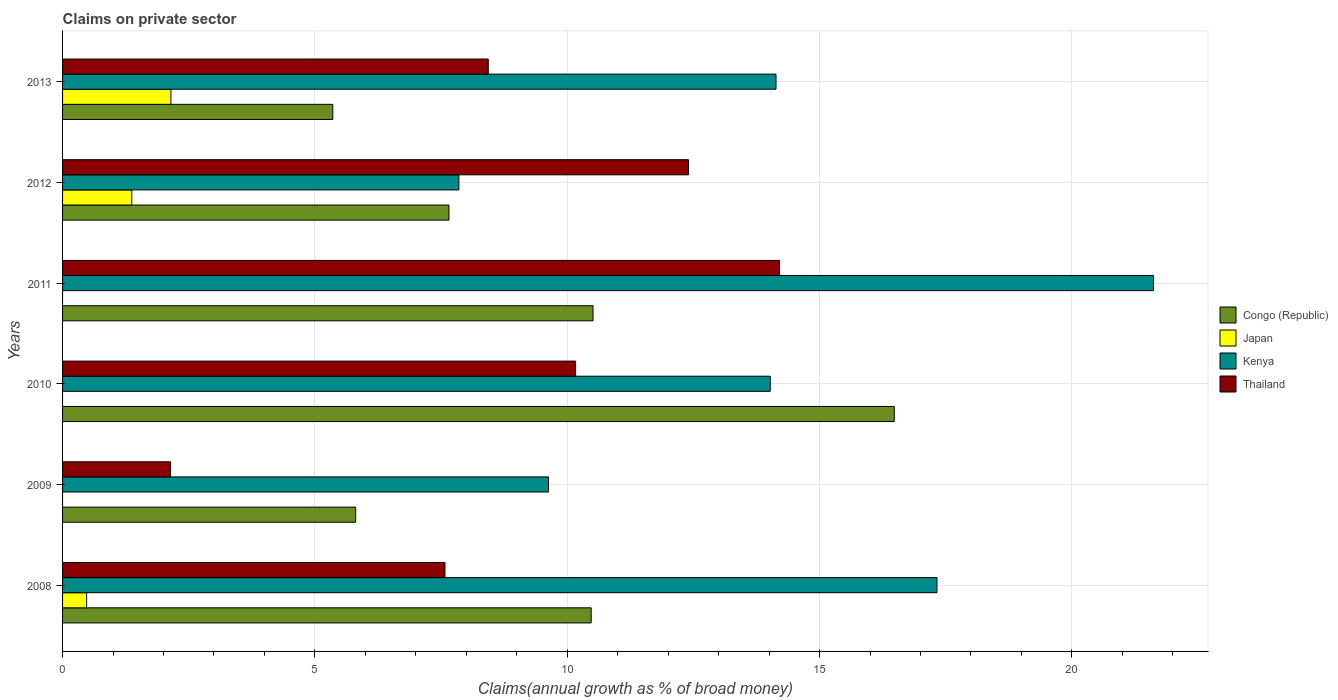How many different coloured bars are there?
Your answer should be compact. 4. How many groups of bars are there?
Provide a short and direct response. 6. How many bars are there on the 4th tick from the bottom?
Give a very brief answer. 3. What is the label of the 3rd group of bars from the top?
Provide a short and direct response. 2011. What is the percentage of broad money claimed on private sector in Congo (Republic) in 2012?
Your answer should be compact. 7.66. Across all years, what is the maximum percentage of broad money claimed on private sector in Congo (Republic)?
Your answer should be very brief. 16.48. Across all years, what is the minimum percentage of broad money claimed on private sector in Kenya?
Give a very brief answer. 7.85. In which year was the percentage of broad money claimed on private sector in Thailand maximum?
Your answer should be compact. 2011. What is the total percentage of broad money claimed on private sector in Thailand in the graph?
Offer a very short reply. 54.93. What is the difference between the percentage of broad money claimed on private sector in Congo (Republic) in 2008 and that in 2012?
Your response must be concise. 2.82. What is the difference between the percentage of broad money claimed on private sector in Congo (Republic) in 2010 and the percentage of broad money claimed on private sector in Kenya in 2011?
Provide a succinct answer. -5.14. What is the average percentage of broad money claimed on private sector in Kenya per year?
Provide a succinct answer. 14.1. In the year 2013, what is the difference between the percentage of broad money claimed on private sector in Congo (Republic) and percentage of broad money claimed on private sector in Thailand?
Keep it short and to the point. -3.08. What is the ratio of the percentage of broad money claimed on private sector in Congo (Republic) in 2009 to that in 2013?
Provide a succinct answer. 1.08. Is the difference between the percentage of broad money claimed on private sector in Congo (Republic) in 2009 and 2012 greater than the difference between the percentage of broad money claimed on private sector in Thailand in 2009 and 2012?
Offer a very short reply. Yes. What is the difference between the highest and the second highest percentage of broad money claimed on private sector in Congo (Republic)?
Your answer should be compact. 5.97. What is the difference between the highest and the lowest percentage of broad money claimed on private sector in Congo (Republic)?
Your answer should be compact. 11.13. Is it the case that in every year, the sum of the percentage of broad money claimed on private sector in Kenya and percentage of broad money claimed on private sector in Thailand is greater than the sum of percentage of broad money claimed on private sector in Japan and percentage of broad money claimed on private sector in Congo (Republic)?
Ensure brevity in your answer.  No. Is it the case that in every year, the sum of the percentage of broad money claimed on private sector in Kenya and percentage of broad money claimed on private sector in Japan is greater than the percentage of broad money claimed on private sector in Thailand?
Your answer should be very brief. No. Are all the bars in the graph horizontal?
Offer a terse response. Yes. What is the difference between two consecutive major ticks on the X-axis?
Make the answer very short. 5. Are the values on the major ticks of X-axis written in scientific E-notation?
Offer a very short reply. No. How many legend labels are there?
Offer a very short reply. 4. What is the title of the graph?
Give a very brief answer. Claims on private sector. Does "North America" appear as one of the legend labels in the graph?
Give a very brief answer. No. What is the label or title of the X-axis?
Offer a terse response. Claims(annual growth as % of broad money). What is the Claims(annual growth as % of broad money) in Congo (Republic) in 2008?
Provide a succinct answer. 10.47. What is the Claims(annual growth as % of broad money) of Japan in 2008?
Offer a terse response. 0.48. What is the Claims(annual growth as % of broad money) of Kenya in 2008?
Provide a short and direct response. 17.33. What is the Claims(annual growth as % of broad money) of Thailand in 2008?
Provide a short and direct response. 7.58. What is the Claims(annual growth as % of broad money) of Congo (Republic) in 2009?
Ensure brevity in your answer.  5.81. What is the Claims(annual growth as % of broad money) in Kenya in 2009?
Give a very brief answer. 9.63. What is the Claims(annual growth as % of broad money) in Thailand in 2009?
Provide a succinct answer. 2.14. What is the Claims(annual growth as % of broad money) in Congo (Republic) in 2010?
Offer a very short reply. 16.48. What is the Claims(annual growth as % of broad money) of Japan in 2010?
Your answer should be compact. 0. What is the Claims(annual growth as % of broad money) of Kenya in 2010?
Your answer should be very brief. 14.02. What is the Claims(annual growth as % of broad money) in Thailand in 2010?
Give a very brief answer. 10.17. What is the Claims(annual growth as % of broad money) in Congo (Republic) in 2011?
Offer a terse response. 10.51. What is the Claims(annual growth as % of broad money) in Japan in 2011?
Your response must be concise. 0. What is the Claims(annual growth as % of broad money) of Kenya in 2011?
Your response must be concise. 21.62. What is the Claims(annual growth as % of broad money) of Thailand in 2011?
Give a very brief answer. 14.21. What is the Claims(annual growth as % of broad money) of Congo (Republic) in 2012?
Keep it short and to the point. 7.66. What is the Claims(annual growth as % of broad money) in Japan in 2012?
Your answer should be very brief. 1.37. What is the Claims(annual growth as % of broad money) in Kenya in 2012?
Offer a very short reply. 7.85. What is the Claims(annual growth as % of broad money) in Thailand in 2012?
Keep it short and to the point. 12.4. What is the Claims(annual growth as % of broad money) of Congo (Republic) in 2013?
Provide a short and direct response. 5.35. What is the Claims(annual growth as % of broad money) of Japan in 2013?
Make the answer very short. 2.15. What is the Claims(annual growth as % of broad money) of Kenya in 2013?
Keep it short and to the point. 14.14. What is the Claims(annual growth as % of broad money) in Thailand in 2013?
Provide a succinct answer. 8.44. Across all years, what is the maximum Claims(annual growth as % of broad money) of Congo (Republic)?
Your answer should be compact. 16.48. Across all years, what is the maximum Claims(annual growth as % of broad money) in Japan?
Keep it short and to the point. 2.15. Across all years, what is the maximum Claims(annual growth as % of broad money) in Kenya?
Make the answer very short. 21.62. Across all years, what is the maximum Claims(annual growth as % of broad money) in Thailand?
Ensure brevity in your answer.  14.21. Across all years, what is the minimum Claims(annual growth as % of broad money) of Congo (Republic)?
Your answer should be compact. 5.35. Across all years, what is the minimum Claims(annual growth as % of broad money) in Kenya?
Your answer should be compact. 7.85. Across all years, what is the minimum Claims(annual growth as % of broad money) of Thailand?
Offer a terse response. 2.14. What is the total Claims(annual growth as % of broad money) of Congo (Republic) in the graph?
Give a very brief answer. 56.29. What is the total Claims(annual growth as % of broad money) in Japan in the graph?
Provide a short and direct response. 3.99. What is the total Claims(annual growth as % of broad money) in Kenya in the graph?
Provide a succinct answer. 84.59. What is the total Claims(annual growth as % of broad money) of Thailand in the graph?
Provide a succinct answer. 54.93. What is the difference between the Claims(annual growth as % of broad money) in Congo (Republic) in 2008 and that in 2009?
Make the answer very short. 4.67. What is the difference between the Claims(annual growth as % of broad money) of Kenya in 2008 and that in 2009?
Ensure brevity in your answer.  7.7. What is the difference between the Claims(annual growth as % of broad money) in Thailand in 2008 and that in 2009?
Offer a very short reply. 5.44. What is the difference between the Claims(annual growth as % of broad money) in Congo (Republic) in 2008 and that in 2010?
Your answer should be compact. -6.01. What is the difference between the Claims(annual growth as % of broad money) of Kenya in 2008 and that in 2010?
Offer a terse response. 3.3. What is the difference between the Claims(annual growth as % of broad money) of Thailand in 2008 and that in 2010?
Keep it short and to the point. -2.59. What is the difference between the Claims(annual growth as % of broad money) in Congo (Republic) in 2008 and that in 2011?
Your answer should be very brief. -0.04. What is the difference between the Claims(annual growth as % of broad money) of Kenya in 2008 and that in 2011?
Offer a very short reply. -4.29. What is the difference between the Claims(annual growth as % of broad money) of Thailand in 2008 and that in 2011?
Make the answer very short. -6.63. What is the difference between the Claims(annual growth as % of broad money) in Congo (Republic) in 2008 and that in 2012?
Make the answer very short. 2.82. What is the difference between the Claims(annual growth as % of broad money) in Japan in 2008 and that in 2012?
Make the answer very short. -0.89. What is the difference between the Claims(annual growth as % of broad money) of Kenya in 2008 and that in 2012?
Your answer should be very brief. 9.47. What is the difference between the Claims(annual growth as % of broad money) of Thailand in 2008 and that in 2012?
Your answer should be compact. -4.83. What is the difference between the Claims(annual growth as % of broad money) of Congo (Republic) in 2008 and that in 2013?
Your response must be concise. 5.12. What is the difference between the Claims(annual growth as % of broad money) of Japan in 2008 and that in 2013?
Your answer should be compact. -1.67. What is the difference between the Claims(annual growth as % of broad money) of Kenya in 2008 and that in 2013?
Make the answer very short. 3.19. What is the difference between the Claims(annual growth as % of broad money) in Thailand in 2008 and that in 2013?
Make the answer very short. -0.86. What is the difference between the Claims(annual growth as % of broad money) of Congo (Republic) in 2009 and that in 2010?
Ensure brevity in your answer.  -10.67. What is the difference between the Claims(annual growth as % of broad money) in Kenya in 2009 and that in 2010?
Provide a succinct answer. -4.39. What is the difference between the Claims(annual growth as % of broad money) in Thailand in 2009 and that in 2010?
Keep it short and to the point. -8.03. What is the difference between the Claims(annual growth as % of broad money) in Congo (Republic) in 2009 and that in 2011?
Provide a short and direct response. -4.7. What is the difference between the Claims(annual growth as % of broad money) of Kenya in 2009 and that in 2011?
Your response must be concise. -11.99. What is the difference between the Claims(annual growth as % of broad money) of Thailand in 2009 and that in 2011?
Provide a short and direct response. -12.07. What is the difference between the Claims(annual growth as % of broad money) of Congo (Republic) in 2009 and that in 2012?
Your response must be concise. -1.85. What is the difference between the Claims(annual growth as % of broad money) in Kenya in 2009 and that in 2012?
Provide a short and direct response. 1.78. What is the difference between the Claims(annual growth as % of broad money) of Thailand in 2009 and that in 2012?
Provide a short and direct response. -10.26. What is the difference between the Claims(annual growth as % of broad money) in Congo (Republic) in 2009 and that in 2013?
Give a very brief answer. 0.45. What is the difference between the Claims(annual growth as % of broad money) in Kenya in 2009 and that in 2013?
Make the answer very short. -4.51. What is the difference between the Claims(annual growth as % of broad money) in Thailand in 2009 and that in 2013?
Provide a short and direct response. -6.3. What is the difference between the Claims(annual growth as % of broad money) in Congo (Republic) in 2010 and that in 2011?
Your response must be concise. 5.97. What is the difference between the Claims(annual growth as % of broad money) in Kenya in 2010 and that in 2011?
Make the answer very short. -7.59. What is the difference between the Claims(annual growth as % of broad money) of Thailand in 2010 and that in 2011?
Keep it short and to the point. -4.04. What is the difference between the Claims(annual growth as % of broad money) in Congo (Republic) in 2010 and that in 2012?
Your response must be concise. 8.82. What is the difference between the Claims(annual growth as % of broad money) of Kenya in 2010 and that in 2012?
Ensure brevity in your answer.  6.17. What is the difference between the Claims(annual growth as % of broad money) of Thailand in 2010 and that in 2012?
Provide a succinct answer. -2.24. What is the difference between the Claims(annual growth as % of broad money) of Congo (Republic) in 2010 and that in 2013?
Your answer should be very brief. 11.13. What is the difference between the Claims(annual growth as % of broad money) in Kenya in 2010 and that in 2013?
Make the answer very short. -0.11. What is the difference between the Claims(annual growth as % of broad money) in Thailand in 2010 and that in 2013?
Provide a succinct answer. 1.73. What is the difference between the Claims(annual growth as % of broad money) in Congo (Republic) in 2011 and that in 2012?
Offer a terse response. 2.85. What is the difference between the Claims(annual growth as % of broad money) in Kenya in 2011 and that in 2012?
Provide a succinct answer. 13.76. What is the difference between the Claims(annual growth as % of broad money) of Thailand in 2011 and that in 2012?
Make the answer very short. 1.8. What is the difference between the Claims(annual growth as % of broad money) of Congo (Republic) in 2011 and that in 2013?
Keep it short and to the point. 5.16. What is the difference between the Claims(annual growth as % of broad money) in Kenya in 2011 and that in 2013?
Keep it short and to the point. 7.48. What is the difference between the Claims(annual growth as % of broad money) of Thailand in 2011 and that in 2013?
Offer a very short reply. 5.77. What is the difference between the Claims(annual growth as % of broad money) of Congo (Republic) in 2012 and that in 2013?
Your response must be concise. 2.3. What is the difference between the Claims(annual growth as % of broad money) of Japan in 2012 and that in 2013?
Provide a short and direct response. -0.78. What is the difference between the Claims(annual growth as % of broad money) in Kenya in 2012 and that in 2013?
Provide a short and direct response. -6.28. What is the difference between the Claims(annual growth as % of broad money) in Thailand in 2012 and that in 2013?
Ensure brevity in your answer.  3.97. What is the difference between the Claims(annual growth as % of broad money) in Congo (Republic) in 2008 and the Claims(annual growth as % of broad money) in Kenya in 2009?
Your answer should be compact. 0.85. What is the difference between the Claims(annual growth as % of broad money) in Congo (Republic) in 2008 and the Claims(annual growth as % of broad money) in Thailand in 2009?
Provide a short and direct response. 8.33. What is the difference between the Claims(annual growth as % of broad money) of Japan in 2008 and the Claims(annual growth as % of broad money) of Kenya in 2009?
Provide a short and direct response. -9.15. What is the difference between the Claims(annual growth as % of broad money) in Japan in 2008 and the Claims(annual growth as % of broad money) in Thailand in 2009?
Your answer should be compact. -1.66. What is the difference between the Claims(annual growth as % of broad money) in Kenya in 2008 and the Claims(annual growth as % of broad money) in Thailand in 2009?
Your response must be concise. 15.19. What is the difference between the Claims(annual growth as % of broad money) of Congo (Republic) in 2008 and the Claims(annual growth as % of broad money) of Kenya in 2010?
Your answer should be compact. -3.55. What is the difference between the Claims(annual growth as % of broad money) in Congo (Republic) in 2008 and the Claims(annual growth as % of broad money) in Thailand in 2010?
Keep it short and to the point. 0.31. What is the difference between the Claims(annual growth as % of broad money) in Japan in 2008 and the Claims(annual growth as % of broad money) in Kenya in 2010?
Your answer should be very brief. -13.55. What is the difference between the Claims(annual growth as % of broad money) in Japan in 2008 and the Claims(annual growth as % of broad money) in Thailand in 2010?
Your response must be concise. -9.69. What is the difference between the Claims(annual growth as % of broad money) in Kenya in 2008 and the Claims(annual growth as % of broad money) in Thailand in 2010?
Ensure brevity in your answer.  7.16. What is the difference between the Claims(annual growth as % of broad money) in Congo (Republic) in 2008 and the Claims(annual growth as % of broad money) in Kenya in 2011?
Provide a short and direct response. -11.14. What is the difference between the Claims(annual growth as % of broad money) in Congo (Republic) in 2008 and the Claims(annual growth as % of broad money) in Thailand in 2011?
Your response must be concise. -3.73. What is the difference between the Claims(annual growth as % of broad money) in Japan in 2008 and the Claims(annual growth as % of broad money) in Kenya in 2011?
Make the answer very short. -21.14. What is the difference between the Claims(annual growth as % of broad money) in Japan in 2008 and the Claims(annual growth as % of broad money) in Thailand in 2011?
Your answer should be compact. -13.73. What is the difference between the Claims(annual growth as % of broad money) of Kenya in 2008 and the Claims(annual growth as % of broad money) of Thailand in 2011?
Provide a short and direct response. 3.12. What is the difference between the Claims(annual growth as % of broad money) of Congo (Republic) in 2008 and the Claims(annual growth as % of broad money) of Japan in 2012?
Your answer should be compact. 9.1. What is the difference between the Claims(annual growth as % of broad money) of Congo (Republic) in 2008 and the Claims(annual growth as % of broad money) of Kenya in 2012?
Keep it short and to the point. 2.62. What is the difference between the Claims(annual growth as % of broad money) in Congo (Republic) in 2008 and the Claims(annual growth as % of broad money) in Thailand in 2012?
Provide a short and direct response. -1.93. What is the difference between the Claims(annual growth as % of broad money) in Japan in 2008 and the Claims(annual growth as % of broad money) in Kenya in 2012?
Offer a very short reply. -7.38. What is the difference between the Claims(annual growth as % of broad money) in Japan in 2008 and the Claims(annual growth as % of broad money) in Thailand in 2012?
Your response must be concise. -11.93. What is the difference between the Claims(annual growth as % of broad money) in Kenya in 2008 and the Claims(annual growth as % of broad money) in Thailand in 2012?
Offer a very short reply. 4.92. What is the difference between the Claims(annual growth as % of broad money) in Congo (Republic) in 2008 and the Claims(annual growth as % of broad money) in Japan in 2013?
Provide a succinct answer. 8.33. What is the difference between the Claims(annual growth as % of broad money) of Congo (Republic) in 2008 and the Claims(annual growth as % of broad money) of Kenya in 2013?
Your answer should be very brief. -3.66. What is the difference between the Claims(annual growth as % of broad money) in Congo (Republic) in 2008 and the Claims(annual growth as % of broad money) in Thailand in 2013?
Your answer should be very brief. 2.04. What is the difference between the Claims(annual growth as % of broad money) in Japan in 2008 and the Claims(annual growth as % of broad money) in Kenya in 2013?
Offer a terse response. -13.66. What is the difference between the Claims(annual growth as % of broad money) of Japan in 2008 and the Claims(annual growth as % of broad money) of Thailand in 2013?
Your answer should be compact. -7.96. What is the difference between the Claims(annual growth as % of broad money) of Kenya in 2008 and the Claims(annual growth as % of broad money) of Thailand in 2013?
Keep it short and to the point. 8.89. What is the difference between the Claims(annual growth as % of broad money) of Congo (Republic) in 2009 and the Claims(annual growth as % of broad money) of Kenya in 2010?
Provide a short and direct response. -8.22. What is the difference between the Claims(annual growth as % of broad money) in Congo (Republic) in 2009 and the Claims(annual growth as % of broad money) in Thailand in 2010?
Your response must be concise. -4.36. What is the difference between the Claims(annual growth as % of broad money) of Kenya in 2009 and the Claims(annual growth as % of broad money) of Thailand in 2010?
Offer a very short reply. -0.54. What is the difference between the Claims(annual growth as % of broad money) of Congo (Republic) in 2009 and the Claims(annual growth as % of broad money) of Kenya in 2011?
Provide a short and direct response. -15.81. What is the difference between the Claims(annual growth as % of broad money) of Congo (Republic) in 2009 and the Claims(annual growth as % of broad money) of Thailand in 2011?
Keep it short and to the point. -8.4. What is the difference between the Claims(annual growth as % of broad money) of Kenya in 2009 and the Claims(annual growth as % of broad money) of Thailand in 2011?
Ensure brevity in your answer.  -4.58. What is the difference between the Claims(annual growth as % of broad money) of Congo (Republic) in 2009 and the Claims(annual growth as % of broad money) of Japan in 2012?
Your response must be concise. 4.44. What is the difference between the Claims(annual growth as % of broad money) of Congo (Republic) in 2009 and the Claims(annual growth as % of broad money) of Kenya in 2012?
Provide a succinct answer. -2.04. What is the difference between the Claims(annual growth as % of broad money) in Congo (Republic) in 2009 and the Claims(annual growth as % of broad money) in Thailand in 2012?
Make the answer very short. -6.6. What is the difference between the Claims(annual growth as % of broad money) of Kenya in 2009 and the Claims(annual growth as % of broad money) of Thailand in 2012?
Offer a terse response. -2.78. What is the difference between the Claims(annual growth as % of broad money) in Congo (Republic) in 2009 and the Claims(annual growth as % of broad money) in Japan in 2013?
Offer a terse response. 3.66. What is the difference between the Claims(annual growth as % of broad money) in Congo (Republic) in 2009 and the Claims(annual growth as % of broad money) in Kenya in 2013?
Make the answer very short. -8.33. What is the difference between the Claims(annual growth as % of broad money) of Congo (Republic) in 2009 and the Claims(annual growth as % of broad money) of Thailand in 2013?
Your response must be concise. -2.63. What is the difference between the Claims(annual growth as % of broad money) in Kenya in 2009 and the Claims(annual growth as % of broad money) in Thailand in 2013?
Give a very brief answer. 1.19. What is the difference between the Claims(annual growth as % of broad money) in Congo (Republic) in 2010 and the Claims(annual growth as % of broad money) in Kenya in 2011?
Provide a succinct answer. -5.14. What is the difference between the Claims(annual growth as % of broad money) of Congo (Republic) in 2010 and the Claims(annual growth as % of broad money) of Thailand in 2011?
Your response must be concise. 2.27. What is the difference between the Claims(annual growth as % of broad money) in Kenya in 2010 and the Claims(annual growth as % of broad money) in Thailand in 2011?
Make the answer very short. -0.18. What is the difference between the Claims(annual growth as % of broad money) of Congo (Republic) in 2010 and the Claims(annual growth as % of broad money) of Japan in 2012?
Give a very brief answer. 15.11. What is the difference between the Claims(annual growth as % of broad money) in Congo (Republic) in 2010 and the Claims(annual growth as % of broad money) in Kenya in 2012?
Your answer should be very brief. 8.63. What is the difference between the Claims(annual growth as % of broad money) of Congo (Republic) in 2010 and the Claims(annual growth as % of broad money) of Thailand in 2012?
Your answer should be compact. 4.08. What is the difference between the Claims(annual growth as % of broad money) in Kenya in 2010 and the Claims(annual growth as % of broad money) in Thailand in 2012?
Ensure brevity in your answer.  1.62. What is the difference between the Claims(annual growth as % of broad money) in Congo (Republic) in 2010 and the Claims(annual growth as % of broad money) in Japan in 2013?
Provide a short and direct response. 14.33. What is the difference between the Claims(annual growth as % of broad money) in Congo (Republic) in 2010 and the Claims(annual growth as % of broad money) in Kenya in 2013?
Ensure brevity in your answer.  2.34. What is the difference between the Claims(annual growth as % of broad money) of Congo (Republic) in 2010 and the Claims(annual growth as % of broad money) of Thailand in 2013?
Ensure brevity in your answer.  8.05. What is the difference between the Claims(annual growth as % of broad money) in Kenya in 2010 and the Claims(annual growth as % of broad money) in Thailand in 2013?
Ensure brevity in your answer.  5.59. What is the difference between the Claims(annual growth as % of broad money) in Congo (Republic) in 2011 and the Claims(annual growth as % of broad money) in Japan in 2012?
Provide a succinct answer. 9.14. What is the difference between the Claims(annual growth as % of broad money) of Congo (Republic) in 2011 and the Claims(annual growth as % of broad money) of Kenya in 2012?
Provide a succinct answer. 2.66. What is the difference between the Claims(annual growth as % of broad money) in Congo (Republic) in 2011 and the Claims(annual growth as % of broad money) in Thailand in 2012?
Your response must be concise. -1.89. What is the difference between the Claims(annual growth as % of broad money) in Kenya in 2011 and the Claims(annual growth as % of broad money) in Thailand in 2012?
Ensure brevity in your answer.  9.21. What is the difference between the Claims(annual growth as % of broad money) in Congo (Republic) in 2011 and the Claims(annual growth as % of broad money) in Japan in 2013?
Keep it short and to the point. 8.36. What is the difference between the Claims(annual growth as % of broad money) in Congo (Republic) in 2011 and the Claims(annual growth as % of broad money) in Kenya in 2013?
Your response must be concise. -3.63. What is the difference between the Claims(annual growth as % of broad money) of Congo (Republic) in 2011 and the Claims(annual growth as % of broad money) of Thailand in 2013?
Ensure brevity in your answer.  2.08. What is the difference between the Claims(annual growth as % of broad money) of Kenya in 2011 and the Claims(annual growth as % of broad money) of Thailand in 2013?
Offer a terse response. 13.18. What is the difference between the Claims(annual growth as % of broad money) in Congo (Republic) in 2012 and the Claims(annual growth as % of broad money) in Japan in 2013?
Offer a very short reply. 5.51. What is the difference between the Claims(annual growth as % of broad money) in Congo (Republic) in 2012 and the Claims(annual growth as % of broad money) in Kenya in 2013?
Give a very brief answer. -6.48. What is the difference between the Claims(annual growth as % of broad money) in Congo (Republic) in 2012 and the Claims(annual growth as % of broad money) in Thailand in 2013?
Give a very brief answer. -0.78. What is the difference between the Claims(annual growth as % of broad money) in Japan in 2012 and the Claims(annual growth as % of broad money) in Kenya in 2013?
Offer a very short reply. -12.77. What is the difference between the Claims(annual growth as % of broad money) of Japan in 2012 and the Claims(annual growth as % of broad money) of Thailand in 2013?
Ensure brevity in your answer.  -7.06. What is the difference between the Claims(annual growth as % of broad money) in Kenya in 2012 and the Claims(annual growth as % of broad money) in Thailand in 2013?
Keep it short and to the point. -0.58. What is the average Claims(annual growth as % of broad money) in Congo (Republic) per year?
Give a very brief answer. 9.38. What is the average Claims(annual growth as % of broad money) of Japan per year?
Your answer should be very brief. 0.67. What is the average Claims(annual growth as % of broad money) of Kenya per year?
Your response must be concise. 14.1. What is the average Claims(annual growth as % of broad money) in Thailand per year?
Ensure brevity in your answer.  9.15. In the year 2008, what is the difference between the Claims(annual growth as % of broad money) of Congo (Republic) and Claims(annual growth as % of broad money) of Japan?
Your response must be concise. 10. In the year 2008, what is the difference between the Claims(annual growth as % of broad money) of Congo (Republic) and Claims(annual growth as % of broad money) of Kenya?
Your answer should be very brief. -6.85. In the year 2008, what is the difference between the Claims(annual growth as % of broad money) of Congo (Republic) and Claims(annual growth as % of broad money) of Thailand?
Your answer should be compact. 2.9. In the year 2008, what is the difference between the Claims(annual growth as % of broad money) in Japan and Claims(annual growth as % of broad money) in Kenya?
Give a very brief answer. -16.85. In the year 2008, what is the difference between the Claims(annual growth as % of broad money) in Japan and Claims(annual growth as % of broad money) in Thailand?
Ensure brevity in your answer.  -7.1. In the year 2008, what is the difference between the Claims(annual growth as % of broad money) in Kenya and Claims(annual growth as % of broad money) in Thailand?
Make the answer very short. 9.75. In the year 2009, what is the difference between the Claims(annual growth as % of broad money) of Congo (Republic) and Claims(annual growth as % of broad money) of Kenya?
Keep it short and to the point. -3.82. In the year 2009, what is the difference between the Claims(annual growth as % of broad money) of Congo (Republic) and Claims(annual growth as % of broad money) of Thailand?
Keep it short and to the point. 3.67. In the year 2009, what is the difference between the Claims(annual growth as % of broad money) in Kenya and Claims(annual growth as % of broad money) in Thailand?
Ensure brevity in your answer.  7.49. In the year 2010, what is the difference between the Claims(annual growth as % of broad money) in Congo (Republic) and Claims(annual growth as % of broad money) in Kenya?
Offer a terse response. 2.46. In the year 2010, what is the difference between the Claims(annual growth as % of broad money) in Congo (Republic) and Claims(annual growth as % of broad money) in Thailand?
Offer a very short reply. 6.31. In the year 2010, what is the difference between the Claims(annual growth as % of broad money) of Kenya and Claims(annual growth as % of broad money) of Thailand?
Keep it short and to the point. 3.86. In the year 2011, what is the difference between the Claims(annual growth as % of broad money) in Congo (Republic) and Claims(annual growth as % of broad money) in Kenya?
Give a very brief answer. -11.11. In the year 2011, what is the difference between the Claims(annual growth as % of broad money) in Congo (Republic) and Claims(annual growth as % of broad money) in Thailand?
Your answer should be very brief. -3.7. In the year 2011, what is the difference between the Claims(annual growth as % of broad money) of Kenya and Claims(annual growth as % of broad money) of Thailand?
Offer a terse response. 7.41. In the year 2012, what is the difference between the Claims(annual growth as % of broad money) in Congo (Republic) and Claims(annual growth as % of broad money) in Japan?
Provide a short and direct response. 6.29. In the year 2012, what is the difference between the Claims(annual growth as % of broad money) in Congo (Republic) and Claims(annual growth as % of broad money) in Kenya?
Keep it short and to the point. -0.2. In the year 2012, what is the difference between the Claims(annual growth as % of broad money) of Congo (Republic) and Claims(annual growth as % of broad money) of Thailand?
Your response must be concise. -4.75. In the year 2012, what is the difference between the Claims(annual growth as % of broad money) in Japan and Claims(annual growth as % of broad money) in Kenya?
Offer a terse response. -6.48. In the year 2012, what is the difference between the Claims(annual growth as % of broad money) of Japan and Claims(annual growth as % of broad money) of Thailand?
Your answer should be very brief. -11.03. In the year 2012, what is the difference between the Claims(annual growth as % of broad money) of Kenya and Claims(annual growth as % of broad money) of Thailand?
Your answer should be compact. -4.55. In the year 2013, what is the difference between the Claims(annual growth as % of broad money) in Congo (Republic) and Claims(annual growth as % of broad money) in Japan?
Your response must be concise. 3.21. In the year 2013, what is the difference between the Claims(annual growth as % of broad money) of Congo (Republic) and Claims(annual growth as % of broad money) of Kenya?
Keep it short and to the point. -8.78. In the year 2013, what is the difference between the Claims(annual growth as % of broad money) of Congo (Republic) and Claims(annual growth as % of broad money) of Thailand?
Keep it short and to the point. -3.08. In the year 2013, what is the difference between the Claims(annual growth as % of broad money) in Japan and Claims(annual growth as % of broad money) in Kenya?
Ensure brevity in your answer.  -11.99. In the year 2013, what is the difference between the Claims(annual growth as % of broad money) in Japan and Claims(annual growth as % of broad money) in Thailand?
Your answer should be very brief. -6.29. In the year 2013, what is the difference between the Claims(annual growth as % of broad money) of Kenya and Claims(annual growth as % of broad money) of Thailand?
Provide a short and direct response. 5.7. What is the ratio of the Claims(annual growth as % of broad money) of Congo (Republic) in 2008 to that in 2009?
Give a very brief answer. 1.8. What is the ratio of the Claims(annual growth as % of broad money) in Kenya in 2008 to that in 2009?
Ensure brevity in your answer.  1.8. What is the ratio of the Claims(annual growth as % of broad money) of Thailand in 2008 to that in 2009?
Your answer should be compact. 3.54. What is the ratio of the Claims(annual growth as % of broad money) of Congo (Republic) in 2008 to that in 2010?
Ensure brevity in your answer.  0.64. What is the ratio of the Claims(annual growth as % of broad money) in Kenya in 2008 to that in 2010?
Make the answer very short. 1.24. What is the ratio of the Claims(annual growth as % of broad money) in Thailand in 2008 to that in 2010?
Offer a very short reply. 0.75. What is the ratio of the Claims(annual growth as % of broad money) of Congo (Republic) in 2008 to that in 2011?
Ensure brevity in your answer.  1. What is the ratio of the Claims(annual growth as % of broad money) in Kenya in 2008 to that in 2011?
Provide a short and direct response. 0.8. What is the ratio of the Claims(annual growth as % of broad money) of Thailand in 2008 to that in 2011?
Make the answer very short. 0.53. What is the ratio of the Claims(annual growth as % of broad money) of Congo (Republic) in 2008 to that in 2012?
Keep it short and to the point. 1.37. What is the ratio of the Claims(annual growth as % of broad money) in Japan in 2008 to that in 2012?
Provide a short and direct response. 0.35. What is the ratio of the Claims(annual growth as % of broad money) of Kenya in 2008 to that in 2012?
Your response must be concise. 2.21. What is the ratio of the Claims(annual growth as % of broad money) of Thailand in 2008 to that in 2012?
Your answer should be very brief. 0.61. What is the ratio of the Claims(annual growth as % of broad money) in Congo (Republic) in 2008 to that in 2013?
Give a very brief answer. 1.96. What is the ratio of the Claims(annual growth as % of broad money) in Japan in 2008 to that in 2013?
Ensure brevity in your answer.  0.22. What is the ratio of the Claims(annual growth as % of broad money) in Kenya in 2008 to that in 2013?
Your answer should be very brief. 1.23. What is the ratio of the Claims(annual growth as % of broad money) of Thailand in 2008 to that in 2013?
Your answer should be compact. 0.9. What is the ratio of the Claims(annual growth as % of broad money) in Congo (Republic) in 2009 to that in 2010?
Provide a short and direct response. 0.35. What is the ratio of the Claims(annual growth as % of broad money) in Kenya in 2009 to that in 2010?
Your answer should be very brief. 0.69. What is the ratio of the Claims(annual growth as % of broad money) of Thailand in 2009 to that in 2010?
Your answer should be very brief. 0.21. What is the ratio of the Claims(annual growth as % of broad money) in Congo (Republic) in 2009 to that in 2011?
Your response must be concise. 0.55. What is the ratio of the Claims(annual growth as % of broad money) in Kenya in 2009 to that in 2011?
Your answer should be compact. 0.45. What is the ratio of the Claims(annual growth as % of broad money) in Thailand in 2009 to that in 2011?
Provide a succinct answer. 0.15. What is the ratio of the Claims(annual growth as % of broad money) of Congo (Republic) in 2009 to that in 2012?
Make the answer very short. 0.76. What is the ratio of the Claims(annual growth as % of broad money) of Kenya in 2009 to that in 2012?
Offer a very short reply. 1.23. What is the ratio of the Claims(annual growth as % of broad money) of Thailand in 2009 to that in 2012?
Your answer should be compact. 0.17. What is the ratio of the Claims(annual growth as % of broad money) in Congo (Republic) in 2009 to that in 2013?
Your answer should be compact. 1.08. What is the ratio of the Claims(annual growth as % of broad money) in Kenya in 2009 to that in 2013?
Provide a succinct answer. 0.68. What is the ratio of the Claims(annual growth as % of broad money) in Thailand in 2009 to that in 2013?
Make the answer very short. 0.25. What is the ratio of the Claims(annual growth as % of broad money) of Congo (Republic) in 2010 to that in 2011?
Offer a terse response. 1.57. What is the ratio of the Claims(annual growth as % of broad money) of Kenya in 2010 to that in 2011?
Ensure brevity in your answer.  0.65. What is the ratio of the Claims(annual growth as % of broad money) of Thailand in 2010 to that in 2011?
Provide a succinct answer. 0.72. What is the ratio of the Claims(annual growth as % of broad money) in Congo (Republic) in 2010 to that in 2012?
Offer a very short reply. 2.15. What is the ratio of the Claims(annual growth as % of broad money) of Kenya in 2010 to that in 2012?
Ensure brevity in your answer.  1.79. What is the ratio of the Claims(annual growth as % of broad money) of Thailand in 2010 to that in 2012?
Your response must be concise. 0.82. What is the ratio of the Claims(annual growth as % of broad money) in Congo (Republic) in 2010 to that in 2013?
Your answer should be compact. 3.08. What is the ratio of the Claims(annual growth as % of broad money) of Kenya in 2010 to that in 2013?
Ensure brevity in your answer.  0.99. What is the ratio of the Claims(annual growth as % of broad money) of Thailand in 2010 to that in 2013?
Offer a terse response. 1.21. What is the ratio of the Claims(annual growth as % of broad money) of Congo (Republic) in 2011 to that in 2012?
Provide a succinct answer. 1.37. What is the ratio of the Claims(annual growth as % of broad money) in Kenya in 2011 to that in 2012?
Provide a succinct answer. 2.75. What is the ratio of the Claims(annual growth as % of broad money) in Thailand in 2011 to that in 2012?
Make the answer very short. 1.15. What is the ratio of the Claims(annual growth as % of broad money) of Congo (Republic) in 2011 to that in 2013?
Your answer should be very brief. 1.96. What is the ratio of the Claims(annual growth as % of broad money) in Kenya in 2011 to that in 2013?
Provide a short and direct response. 1.53. What is the ratio of the Claims(annual growth as % of broad money) of Thailand in 2011 to that in 2013?
Offer a very short reply. 1.68. What is the ratio of the Claims(annual growth as % of broad money) in Congo (Republic) in 2012 to that in 2013?
Provide a short and direct response. 1.43. What is the ratio of the Claims(annual growth as % of broad money) of Japan in 2012 to that in 2013?
Your answer should be very brief. 0.64. What is the ratio of the Claims(annual growth as % of broad money) of Kenya in 2012 to that in 2013?
Give a very brief answer. 0.56. What is the ratio of the Claims(annual growth as % of broad money) in Thailand in 2012 to that in 2013?
Keep it short and to the point. 1.47. What is the difference between the highest and the second highest Claims(annual growth as % of broad money) of Congo (Republic)?
Your answer should be very brief. 5.97. What is the difference between the highest and the second highest Claims(annual growth as % of broad money) in Japan?
Make the answer very short. 0.78. What is the difference between the highest and the second highest Claims(annual growth as % of broad money) of Kenya?
Your answer should be very brief. 4.29. What is the difference between the highest and the second highest Claims(annual growth as % of broad money) in Thailand?
Your answer should be compact. 1.8. What is the difference between the highest and the lowest Claims(annual growth as % of broad money) in Congo (Republic)?
Provide a short and direct response. 11.13. What is the difference between the highest and the lowest Claims(annual growth as % of broad money) of Japan?
Your response must be concise. 2.15. What is the difference between the highest and the lowest Claims(annual growth as % of broad money) of Kenya?
Your answer should be compact. 13.76. What is the difference between the highest and the lowest Claims(annual growth as % of broad money) in Thailand?
Your response must be concise. 12.07. 